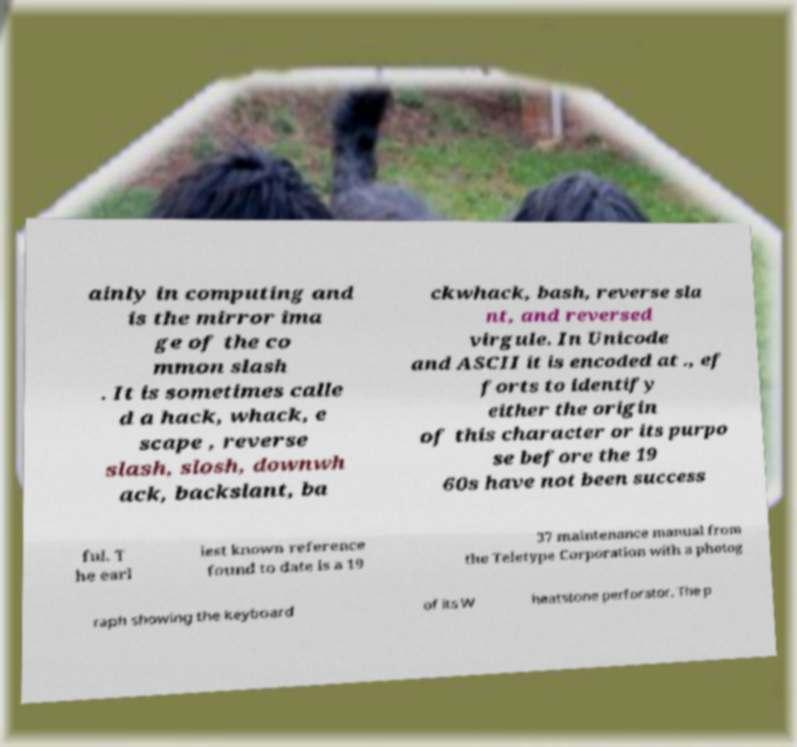Can you accurately transcribe the text from the provided image for me? ainly in computing and is the mirror ima ge of the co mmon slash . It is sometimes calle d a hack, whack, e scape , reverse slash, slosh, downwh ack, backslant, ba ckwhack, bash, reverse sla nt, and reversed virgule. In Unicode and ASCII it is encoded at ., ef forts to identify either the origin of this character or its purpo se before the 19 60s have not been success ful. T he earl iest known reference found to date is a 19 37 maintenance manual from the Teletype Corporation with a photog raph showing the keyboard of its W heatstone perforator. The p 